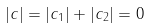Convert formula to latex. <formula><loc_0><loc_0><loc_500><loc_500>| c | = | c _ { 1 } | + | c _ { 2 } | = 0</formula> 